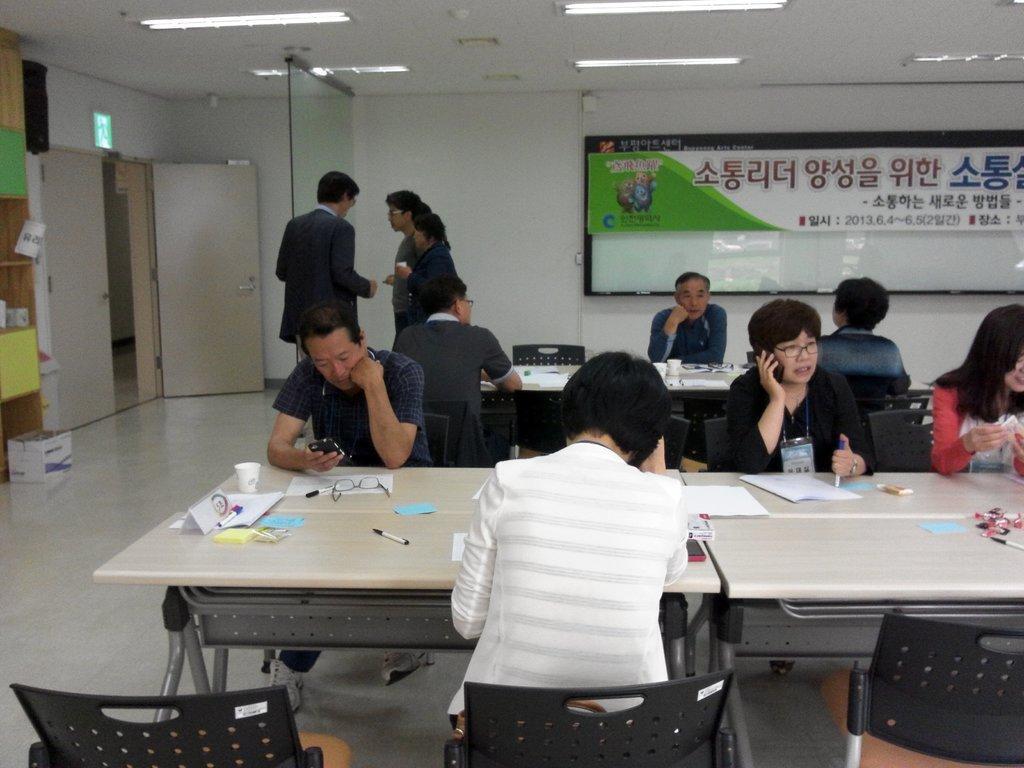Describe this image in one or two sentences. In this image we can see people sitting. There are chairs and tables. We can see papers, glasses, pens and some objects placed on the tables. In the background there is a board, people and a door. At the top there are lights. 